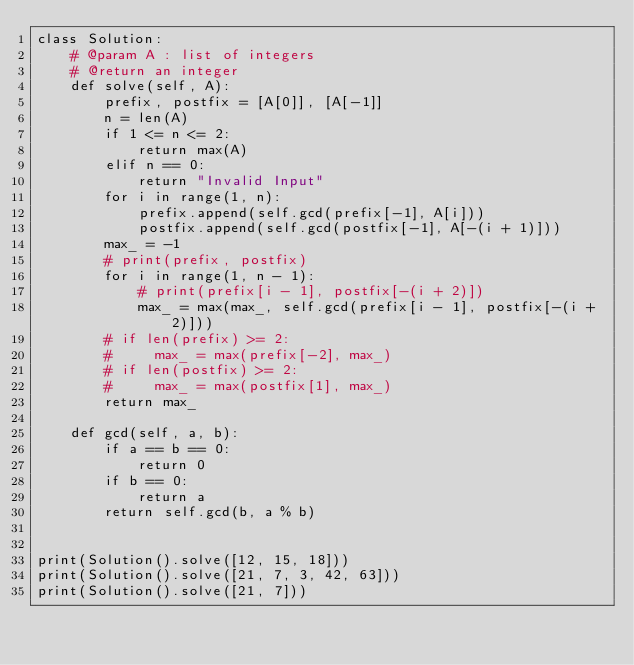Convert code to text. <code><loc_0><loc_0><loc_500><loc_500><_Python_>class Solution:
    # @param A : list of integers
    # @return an integer
    def solve(self, A):
        prefix, postfix = [A[0]], [A[-1]]
        n = len(A)
        if 1 <= n <= 2:
            return max(A)
        elif n == 0:
            return "Invalid Input"
        for i in range(1, n):
            prefix.append(self.gcd(prefix[-1], A[i]))
            postfix.append(self.gcd(postfix[-1], A[-(i + 1)]))
        max_ = -1
        # print(prefix, postfix)
        for i in range(1, n - 1):
            # print(prefix[i - 1], postfix[-(i + 2)])
            max_ = max(max_, self.gcd(prefix[i - 1], postfix[-(i + 2)]))
        # if len(prefix) >= 2:
        #     max_ = max(prefix[-2], max_)
        # if len(postfix) >= 2:
        #     max_ = max(postfix[1], max_)
        return max_

    def gcd(self, a, b):
        if a == b == 0:
            return 0
        if b == 0:
            return a
        return self.gcd(b, a % b)


print(Solution().solve([12, 15, 18]))
print(Solution().solve([21, 7, 3, 42, 63]))
print(Solution().solve([21, 7]))
</code> 